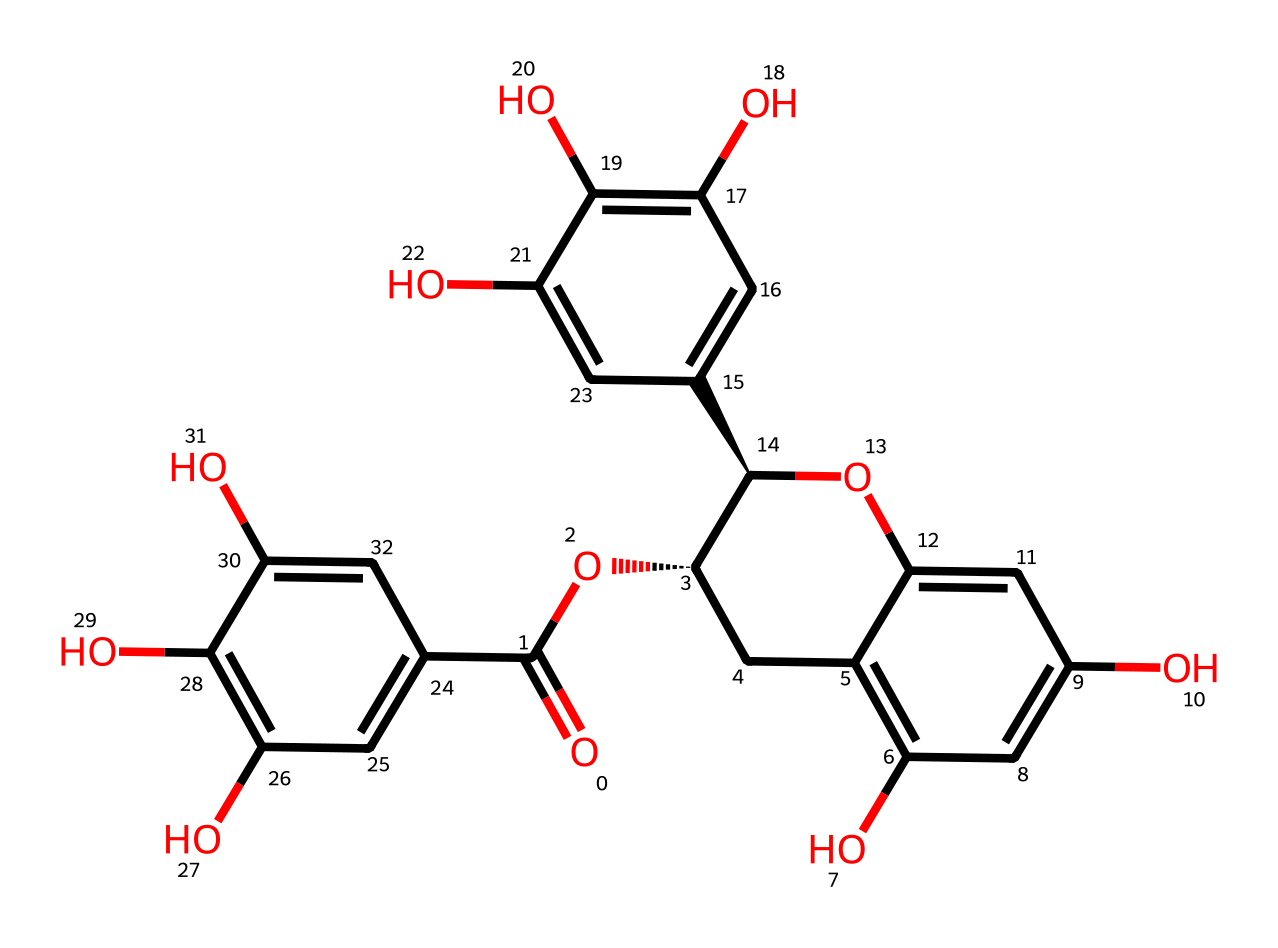What is the molecular formula of the depicted catechin? To find the molecular formula, we first identify the numbers of each type of atom present in the chemical structure. Counting the carbon (C), hydrogen (H), and oxygen (O) atoms yields a total of 21 carbon atoms, 20 hydrogen atoms, and 10 oxygen atoms. Hence, the molecular formula is C21H20O10.
Answer: C21H20O10 How many hydroxyl groups are present in this catechin structure? A hydroxyl group is characterized by the presence of an –OH functional group. By examining the chemical structure, we can identify the presence of at least five –OH groups attached to various benzene rings. Thus, there are 5 hydroxyl groups.
Answer: 5 What type of chemical compound is catechin? Catechin is classified as a flavonoid, specifically a type of phenolic compound. In analyzing its structure, the presence of multiple aromatic rings and hydroxyl groups points to its classification as a flavonoid, particularly due to its structure.
Answer: flavonoid Which part of the catechin structure is primarily responsible for its antioxidant properties? The phenolic hydroxyl groups are primarily responsible for the antioxidant activity. These groups can donate hydrogen atoms to free radicals, thereby neutralizing them. The presence of multiple phenolic units enhances this property.
Answer: phenolic hydroxyl groups What is the total number of rings present in the chemical structure? Upon inspection of the chemical structure, two distinct aromatic rings can be counted among the sections of the structure. Therefore, the total number of rings in this catechin structure is two.
Answer: 2 